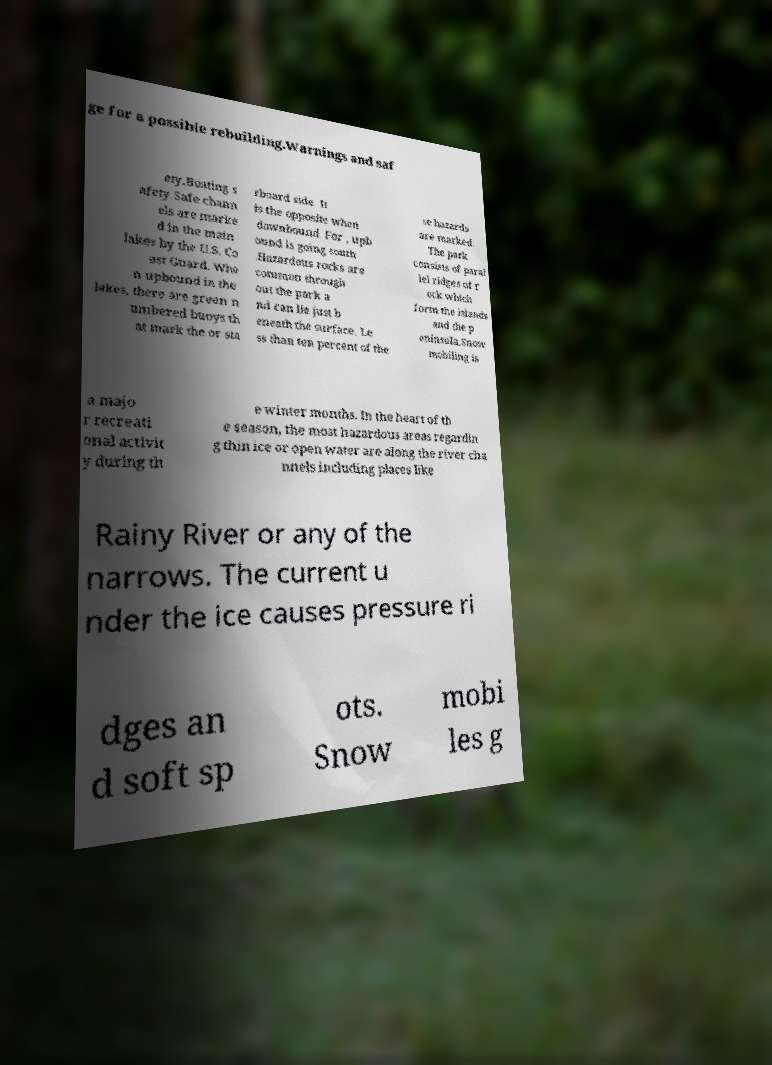What messages or text are displayed in this image? I need them in a readable, typed format. ge for a possible rebuilding.Warnings and saf ety.Boating s afety.Safe chann els are marke d in the main lakes by the U.S. Co ast Guard. Whe n upbound in the lakes, there are green n umbered buoys th at mark the or sta rboard side. It is the opposite when downbound. For , upb ound is going south .Hazardous rocks are common through out the park a nd can lie just b eneath the surface. Le ss than ten percent of the se hazards are marked. The park consists of paral lel ridges of r ock which form the islands and the p eninsula.Snow mobiling is a majo r recreati onal activit y during th e winter months. In the heart of th e season, the most hazardous areas regardin g thin ice or open water are along the river cha nnels including places like Rainy River or any of the narrows. The current u nder the ice causes pressure ri dges an d soft sp ots. Snow mobi les g 